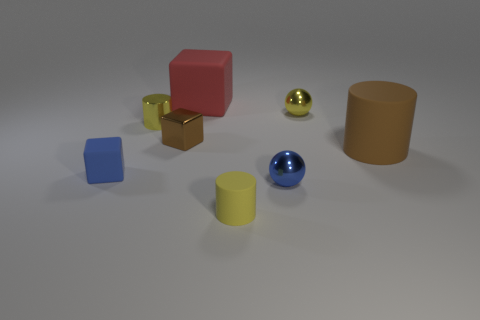Add 1 matte things. How many objects exist? 9 Subtract all blue rubber objects. Subtract all yellow matte objects. How many objects are left? 6 Add 5 small cylinders. How many small cylinders are left? 7 Add 8 yellow cubes. How many yellow cubes exist? 8 Subtract 1 blue spheres. How many objects are left? 7 Subtract all spheres. How many objects are left? 6 